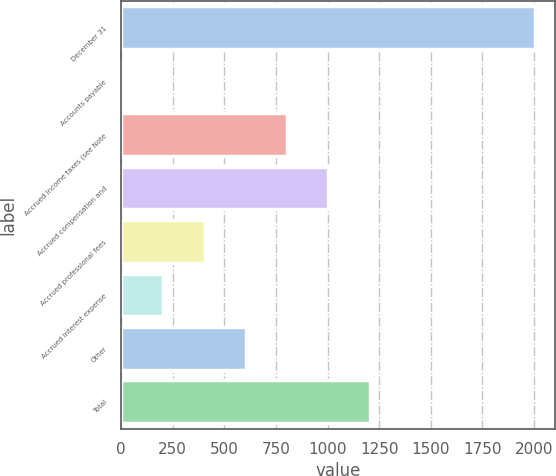Convert chart. <chart><loc_0><loc_0><loc_500><loc_500><bar_chart><fcel>December 31<fcel>Accounts payable<fcel>Accrued income taxes (see Note<fcel>Accrued compensation and<fcel>Accrued professional fees<fcel>Accrued interest expense<fcel>Other<fcel>Total<nl><fcel>2003<fcel>4.4<fcel>803.84<fcel>1003.7<fcel>404.12<fcel>204.26<fcel>603.98<fcel>1203.56<nl></chart> 